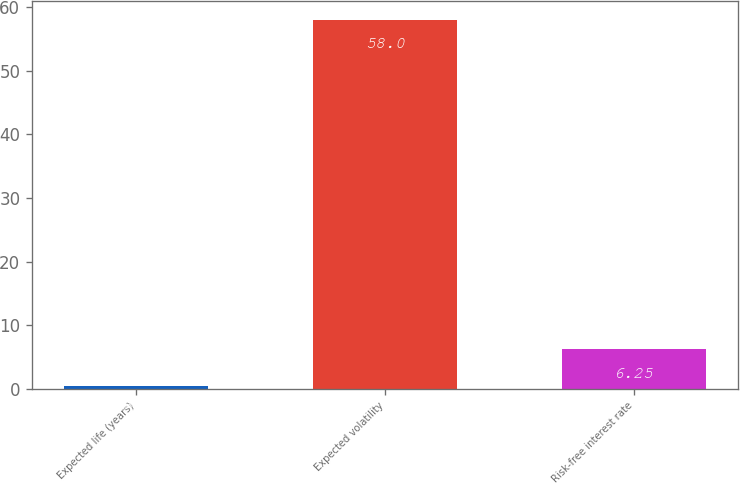Convert chart to OTSL. <chart><loc_0><loc_0><loc_500><loc_500><bar_chart><fcel>Expected life (years)<fcel>Expected volatility<fcel>Risk-free interest rate<nl><fcel>0.5<fcel>58<fcel>6.25<nl></chart> 